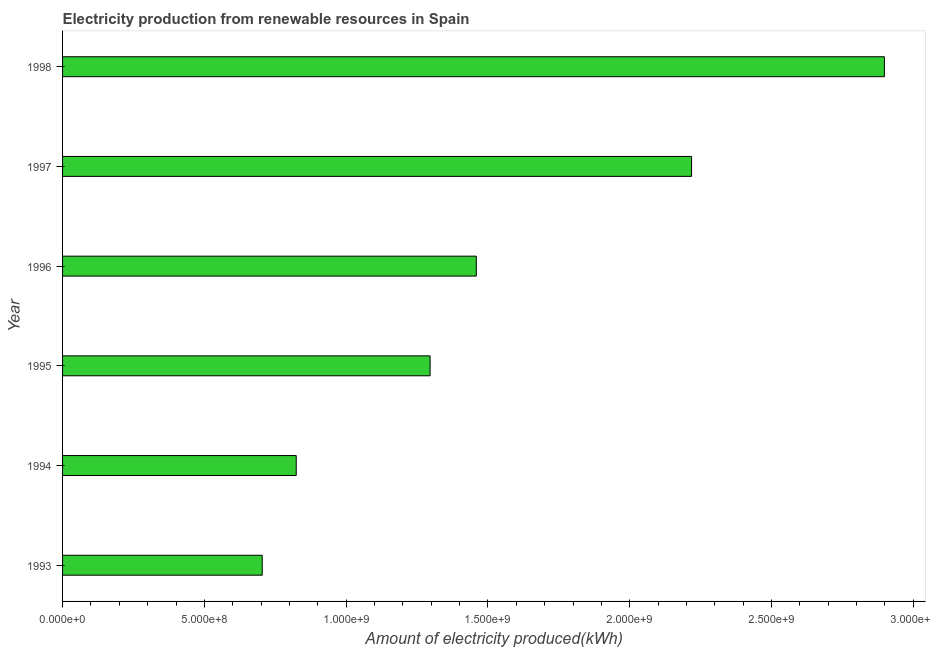Does the graph contain any zero values?
Your response must be concise. No. What is the title of the graph?
Provide a short and direct response. Electricity production from renewable resources in Spain. What is the label or title of the X-axis?
Give a very brief answer. Amount of electricity produced(kWh). What is the label or title of the Y-axis?
Make the answer very short. Year. What is the amount of electricity produced in 1995?
Give a very brief answer. 1.30e+09. Across all years, what is the maximum amount of electricity produced?
Your response must be concise. 2.90e+09. Across all years, what is the minimum amount of electricity produced?
Give a very brief answer. 7.04e+08. What is the sum of the amount of electricity produced?
Ensure brevity in your answer.  9.40e+09. What is the difference between the amount of electricity produced in 1994 and 1996?
Give a very brief answer. -6.35e+08. What is the average amount of electricity produced per year?
Keep it short and to the point. 1.57e+09. What is the median amount of electricity produced?
Offer a terse response. 1.38e+09. Do a majority of the years between 1995 and 1996 (inclusive) have amount of electricity produced greater than 1900000000 kWh?
Provide a short and direct response. No. What is the ratio of the amount of electricity produced in 1994 to that in 1995?
Offer a very short reply. 0.64. Is the amount of electricity produced in 1994 less than that in 1996?
Ensure brevity in your answer.  Yes. Is the difference between the amount of electricity produced in 1994 and 1995 greater than the difference between any two years?
Give a very brief answer. No. What is the difference between the highest and the second highest amount of electricity produced?
Offer a terse response. 6.80e+08. Is the sum of the amount of electricity produced in 1997 and 1998 greater than the maximum amount of electricity produced across all years?
Your answer should be compact. Yes. What is the difference between the highest and the lowest amount of electricity produced?
Your answer should be compact. 2.19e+09. In how many years, is the amount of electricity produced greater than the average amount of electricity produced taken over all years?
Your answer should be compact. 2. How many bars are there?
Your answer should be compact. 6. What is the difference between two consecutive major ticks on the X-axis?
Provide a short and direct response. 5.00e+08. What is the Amount of electricity produced(kWh) of 1993?
Ensure brevity in your answer.  7.04e+08. What is the Amount of electricity produced(kWh) in 1994?
Offer a very short reply. 8.24e+08. What is the Amount of electricity produced(kWh) in 1995?
Provide a short and direct response. 1.30e+09. What is the Amount of electricity produced(kWh) in 1996?
Provide a succinct answer. 1.46e+09. What is the Amount of electricity produced(kWh) of 1997?
Your answer should be very brief. 2.22e+09. What is the Amount of electricity produced(kWh) of 1998?
Your answer should be very brief. 2.90e+09. What is the difference between the Amount of electricity produced(kWh) in 1993 and 1994?
Your answer should be very brief. -1.20e+08. What is the difference between the Amount of electricity produced(kWh) in 1993 and 1995?
Provide a succinct answer. -5.92e+08. What is the difference between the Amount of electricity produced(kWh) in 1993 and 1996?
Your answer should be compact. -7.55e+08. What is the difference between the Amount of electricity produced(kWh) in 1993 and 1997?
Offer a terse response. -1.51e+09. What is the difference between the Amount of electricity produced(kWh) in 1993 and 1998?
Give a very brief answer. -2.19e+09. What is the difference between the Amount of electricity produced(kWh) in 1994 and 1995?
Your answer should be very brief. -4.72e+08. What is the difference between the Amount of electricity produced(kWh) in 1994 and 1996?
Make the answer very short. -6.35e+08. What is the difference between the Amount of electricity produced(kWh) in 1994 and 1997?
Give a very brief answer. -1.39e+09. What is the difference between the Amount of electricity produced(kWh) in 1994 and 1998?
Provide a succinct answer. -2.07e+09. What is the difference between the Amount of electricity produced(kWh) in 1995 and 1996?
Provide a succinct answer. -1.63e+08. What is the difference between the Amount of electricity produced(kWh) in 1995 and 1997?
Give a very brief answer. -9.22e+08. What is the difference between the Amount of electricity produced(kWh) in 1995 and 1998?
Provide a short and direct response. -1.60e+09. What is the difference between the Amount of electricity produced(kWh) in 1996 and 1997?
Your answer should be very brief. -7.59e+08. What is the difference between the Amount of electricity produced(kWh) in 1996 and 1998?
Ensure brevity in your answer.  -1.44e+09. What is the difference between the Amount of electricity produced(kWh) in 1997 and 1998?
Your answer should be compact. -6.80e+08. What is the ratio of the Amount of electricity produced(kWh) in 1993 to that in 1994?
Offer a very short reply. 0.85. What is the ratio of the Amount of electricity produced(kWh) in 1993 to that in 1995?
Your answer should be compact. 0.54. What is the ratio of the Amount of electricity produced(kWh) in 1993 to that in 1996?
Offer a very short reply. 0.48. What is the ratio of the Amount of electricity produced(kWh) in 1993 to that in 1997?
Provide a succinct answer. 0.32. What is the ratio of the Amount of electricity produced(kWh) in 1993 to that in 1998?
Your response must be concise. 0.24. What is the ratio of the Amount of electricity produced(kWh) in 1994 to that in 1995?
Provide a short and direct response. 0.64. What is the ratio of the Amount of electricity produced(kWh) in 1994 to that in 1996?
Offer a terse response. 0.56. What is the ratio of the Amount of electricity produced(kWh) in 1994 to that in 1997?
Offer a terse response. 0.37. What is the ratio of the Amount of electricity produced(kWh) in 1994 to that in 1998?
Keep it short and to the point. 0.28. What is the ratio of the Amount of electricity produced(kWh) in 1995 to that in 1996?
Ensure brevity in your answer.  0.89. What is the ratio of the Amount of electricity produced(kWh) in 1995 to that in 1997?
Provide a succinct answer. 0.58. What is the ratio of the Amount of electricity produced(kWh) in 1995 to that in 1998?
Your answer should be very brief. 0.45. What is the ratio of the Amount of electricity produced(kWh) in 1996 to that in 1997?
Your answer should be very brief. 0.66. What is the ratio of the Amount of electricity produced(kWh) in 1996 to that in 1998?
Make the answer very short. 0.5. What is the ratio of the Amount of electricity produced(kWh) in 1997 to that in 1998?
Your answer should be compact. 0.77. 